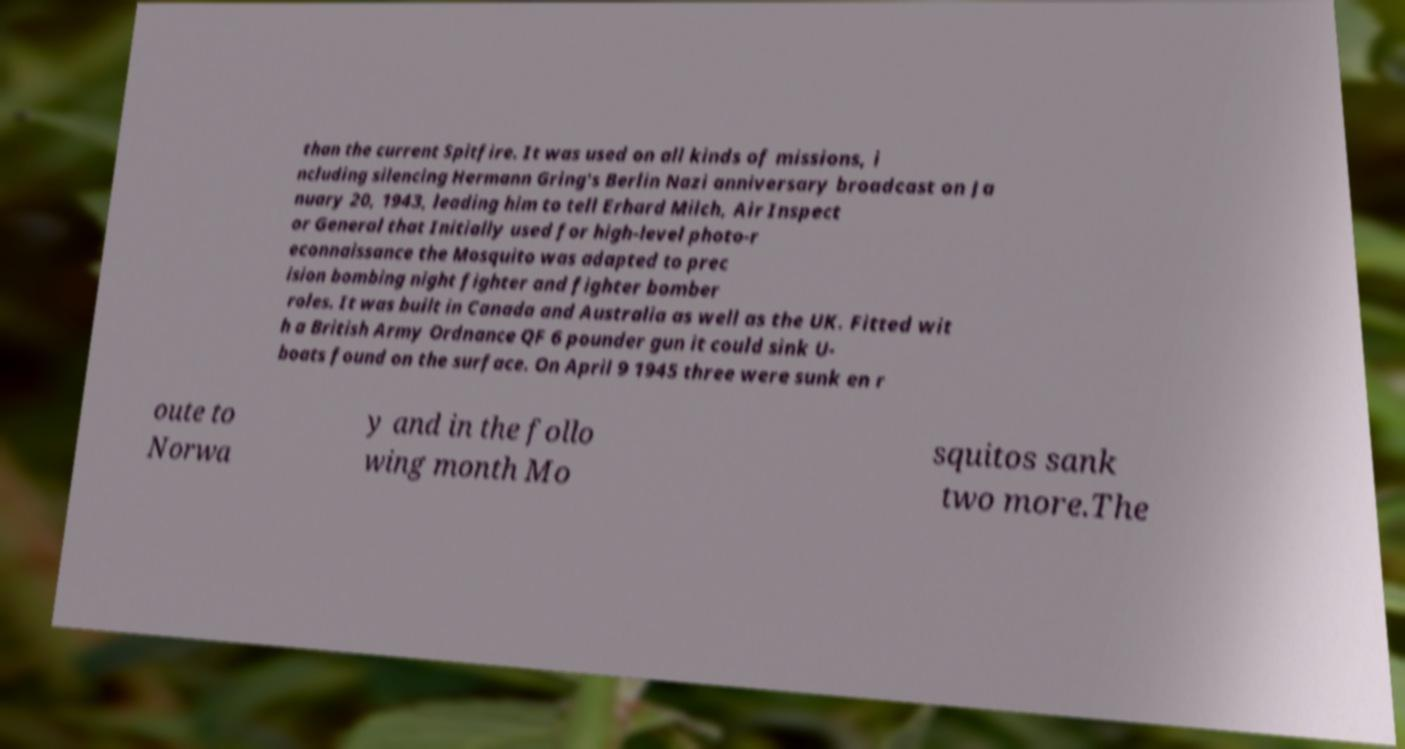I need the written content from this picture converted into text. Can you do that? than the current Spitfire. It was used on all kinds of missions, i ncluding silencing Hermann Gring's Berlin Nazi anniversary broadcast on Ja nuary 20, 1943, leading him to tell Erhard Milch, Air Inspect or General that Initially used for high-level photo-r econnaissance the Mosquito was adapted to prec ision bombing night fighter and fighter bomber roles. It was built in Canada and Australia as well as the UK. Fitted wit h a British Army Ordnance QF 6 pounder gun it could sink U- boats found on the surface. On April 9 1945 three were sunk en r oute to Norwa y and in the follo wing month Mo squitos sank two more.The 